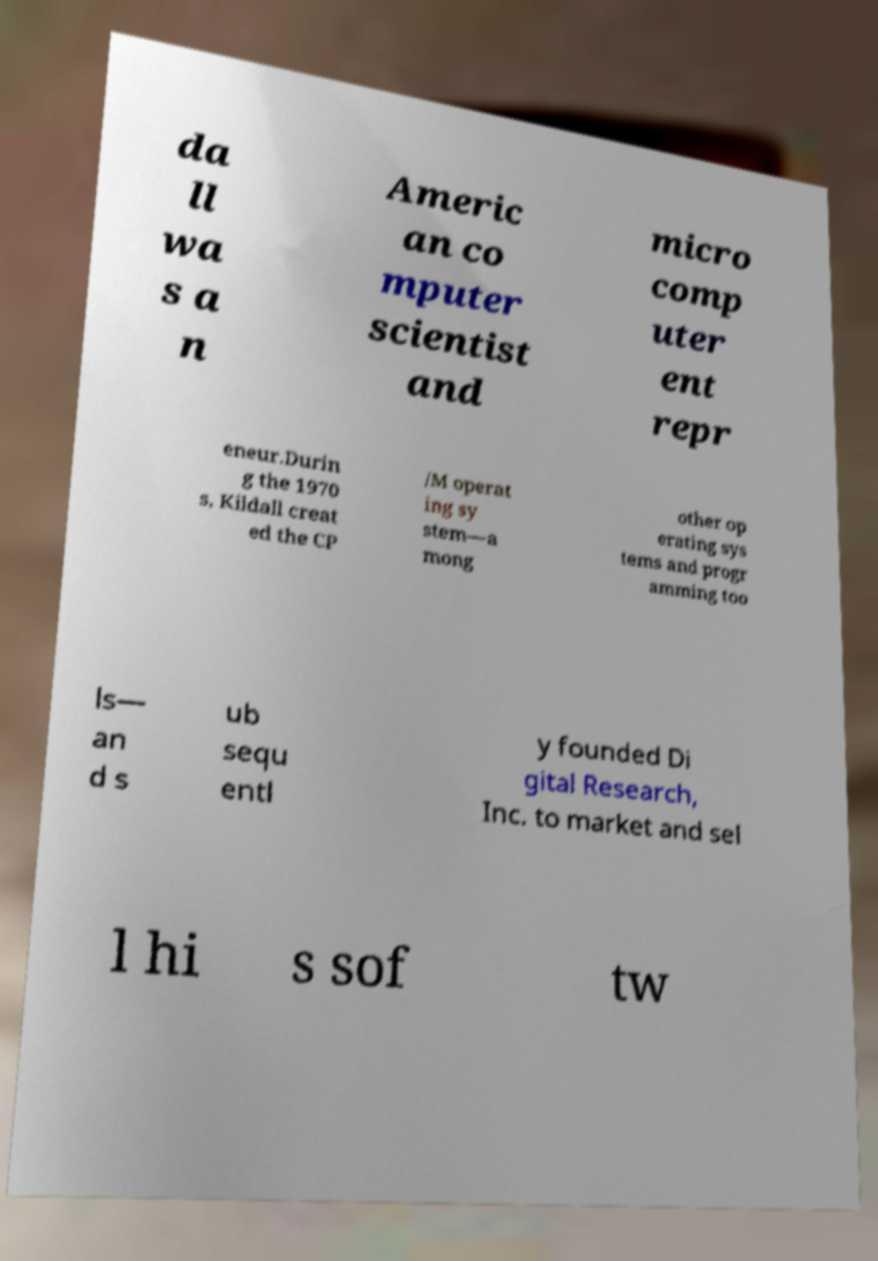Can you read and provide the text displayed in the image?This photo seems to have some interesting text. Can you extract and type it out for me? da ll wa s a n Americ an co mputer scientist and micro comp uter ent repr eneur.Durin g the 1970 s, Kildall creat ed the CP /M operat ing sy stem—a mong other op erating sys tems and progr amming too ls— an d s ub sequ entl y founded Di gital Research, Inc. to market and sel l hi s sof tw 